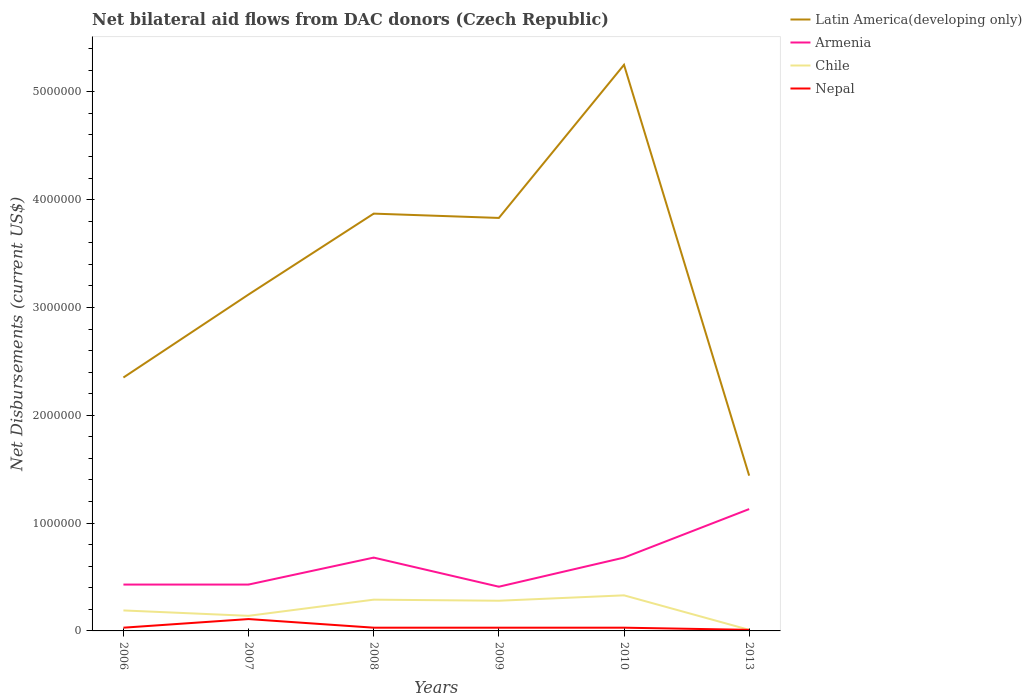How many different coloured lines are there?
Provide a succinct answer. 4. Does the line corresponding to Chile intersect with the line corresponding to Latin America(developing only)?
Provide a succinct answer. No. Across all years, what is the maximum net bilateral aid flows in Armenia?
Provide a succinct answer. 4.10e+05. In which year was the net bilateral aid flows in Latin America(developing only) maximum?
Your response must be concise. 2013. What is the total net bilateral aid flows in Nepal in the graph?
Your answer should be very brief. 8.00e+04. What is the difference between the highest and the second highest net bilateral aid flows in Armenia?
Keep it short and to the point. 7.20e+05. Is the net bilateral aid flows in Armenia strictly greater than the net bilateral aid flows in Nepal over the years?
Your answer should be very brief. No. How many years are there in the graph?
Your answer should be compact. 6. Are the values on the major ticks of Y-axis written in scientific E-notation?
Offer a terse response. No. Does the graph contain any zero values?
Your answer should be compact. No. Where does the legend appear in the graph?
Give a very brief answer. Top right. How many legend labels are there?
Ensure brevity in your answer.  4. What is the title of the graph?
Offer a terse response. Net bilateral aid flows from DAC donors (Czech Republic). Does "Hungary" appear as one of the legend labels in the graph?
Offer a terse response. No. What is the label or title of the Y-axis?
Ensure brevity in your answer.  Net Disbursements (current US$). What is the Net Disbursements (current US$) of Latin America(developing only) in 2006?
Make the answer very short. 2.35e+06. What is the Net Disbursements (current US$) in Chile in 2006?
Provide a short and direct response. 1.90e+05. What is the Net Disbursements (current US$) in Latin America(developing only) in 2007?
Give a very brief answer. 3.12e+06. What is the Net Disbursements (current US$) in Armenia in 2007?
Make the answer very short. 4.30e+05. What is the Net Disbursements (current US$) in Nepal in 2007?
Your answer should be compact. 1.10e+05. What is the Net Disbursements (current US$) of Latin America(developing only) in 2008?
Offer a very short reply. 3.87e+06. What is the Net Disbursements (current US$) of Armenia in 2008?
Your response must be concise. 6.80e+05. What is the Net Disbursements (current US$) in Chile in 2008?
Offer a very short reply. 2.90e+05. What is the Net Disbursements (current US$) in Latin America(developing only) in 2009?
Your answer should be compact. 3.83e+06. What is the Net Disbursements (current US$) in Armenia in 2009?
Your answer should be very brief. 4.10e+05. What is the Net Disbursements (current US$) in Chile in 2009?
Your answer should be compact. 2.80e+05. What is the Net Disbursements (current US$) in Latin America(developing only) in 2010?
Make the answer very short. 5.25e+06. What is the Net Disbursements (current US$) in Armenia in 2010?
Make the answer very short. 6.80e+05. What is the Net Disbursements (current US$) of Chile in 2010?
Give a very brief answer. 3.30e+05. What is the Net Disbursements (current US$) in Latin America(developing only) in 2013?
Your response must be concise. 1.44e+06. What is the Net Disbursements (current US$) in Armenia in 2013?
Your response must be concise. 1.13e+06. What is the Net Disbursements (current US$) in Chile in 2013?
Offer a very short reply. 10000. Across all years, what is the maximum Net Disbursements (current US$) of Latin America(developing only)?
Your answer should be compact. 5.25e+06. Across all years, what is the maximum Net Disbursements (current US$) of Armenia?
Provide a succinct answer. 1.13e+06. Across all years, what is the minimum Net Disbursements (current US$) of Latin America(developing only)?
Your answer should be very brief. 1.44e+06. Across all years, what is the minimum Net Disbursements (current US$) in Armenia?
Provide a short and direct response. 4.10e+05. Across all years, what is the minimum Net Disbursements (current US$) in Chile?
Offer a very short reply. 10000. Across all years, what is the minimum Net Disbursements (current US$) of Nepal?
Make the answer very short. 10000. What is the total Net Disbursements (current US$) of Latin America(developing only) in the graph?
Provide a succinct answer. 1.99e+07. What is the total Net Disbursements (current US$) in Armenia in the graph?
Give a very brief answer. 3.76e+06. What is the total Net Disbursements (current US$) in Chile in the graph?
Make the answer very short. 1.24e+06. What is the total Net Disbursements (current US$) in Nepal in the graph?
Offer a very short reply. 2.40e+05. What is the difference between the Net Disbursements (current US$) in Latin America(developing only) in 2006 and that in 2007?
Your answer should be compact. -7.70e+05. What is the difference between the Net Disbursements (current US$) of Latin America(developing only) in 2006 and that in 2008?
Give a very brief answer. -1.52e+06. What is the difference between the Net Disbursements (current US$) of Latin America(developing only) in 2006 and that in 2009?
Provide a succinct answer. -1.48e+06. What is the difference between the Net Disbursements (current US$) in Armenia in 2006 and that in 2009?
Offer a terse response. 2.00e+04. What is the difference between the Net Disbursements (current US$) of Chile in 2006 and that in 2009?
Ensure brevity in your answer.  -9.00e+04. What is the difference between the Net Disbursements (current US$) of Latin America(developing only) in 2006 and that in 2010?
Your answer should be compact. -2.90e+06. What is the difference between the Net Disbursements (current US$) of Chile in 2006 and that in 2010?
Offer a terse response. -1.40e+05. What is the difference between the Net Disbursements (current US$) in Latin America(developing only) in 2006 and that in 2013?
Make the answer very short. 9.10e+05. What is the difference between the Net Disbursements (current US$) in Armenia in 2006 and that in 2013?
Your answer should be compact. -7.00e+05. What is the difference between the Net Disbursements (current US$) in Chile in 2006 and that in 2013?
Make the answer very short. 1.80e+05. What is the difference between the Net Disbursements (current US$) of Latin America(developing only) in 2007 and that in 2008?
Your answer should be compact. -7.50e+05. What is the difference between the Net Disbursements (current US$) of Armenia in 2007 and that in 2008?
Ensure brevity in your answer.  -2.50e+05. What is the difference between the Net Disbursements (current US$) in Chile in 2007 and that in 2008?
Make the answer very short. -1.50e+05. What is the difference between the Net Disbursements (current US$) of Latin America(developing only) in 2007 and that in 2009?
Offer a very short reply. -7.10e+05. What is the difference between the Net Disbursements (current US$) in Nepal in 2007 and that in 2009?
Ensure brevity in your answer.  8.00e+04. What is the difference between the Net Disbursements (current US$) in Latin America(developing only) in 2007 and that in 2010?
Provide a short and direct response. -2.13e+06. What is the difference between the Net Disbursements (current US$) of Armenia in 2007 and that in 2010?
Your response must be concise. -2.50e+05. What is the difference between the Net Disbursements (current US$) of Chile in 2007 and that in 2010?
Your response must be concise. -1.90e+05. What is the difference between the Net Disbursements (current US$) in Nepal in 2007 and that in 2010?
Keep it short and to the point. 8.00e+04. What is the difference between the Net Disbursements (current US$) in Latin America(developing only) in 2007 and that in 2013?
Ensure brevity in your answer.  1.68e+06. What is the difference between the Net Disbursements (current US$) of Armenia in 2007 and that in 2013?
Provide a short and direct response. -7.00e+05. What is the difference between the Net Disbursements (current US$) in Chile in 2007 and that in 2013?
Offer a very short reply. 1.30e+05. What is the difference between the Net Disbursements (current US$) in Nepal in 2007 and that in 2013?
Offer a very short reply. 1.00e+05. What is the difference between the Net Disbursements (current US$) in Latin America(developing only) in 2008 and that in 2009?
Offer a very short reply. 4.00e+04. What is the difference between the Net Disbursements (current US$) of Armenia in 2008 and that in 2009?
Your answer should be very brief. 2.70e+05. What is the difference between the Net Disbursements (current US$) in Nepal in 2008 and that in 2009?
Offer a very short reply. 0. What is the difference between the Net Disbursements (current US$) of Latin America(developing only) in 2008 and that in 2010?
Your answer should be compact. -1.38e+06. What is the difference between the Net Disbursements (current US$) of Armenia in 2008 and that in 2010?
Provide a succinct answer. 0. What is the difference between the Net Disbursements (current US$) in Latin America(developing only) in 2008 and that in 2013?
Keep it short and to the point. 2.43e+06. What is the difference between the Net Disbursements (current US$) in Armenia in 2008 and that in 2013?
Offer a terse response. -4.50e+05. What is the difference between the Net Disbursements (current US$) in Chile in 2008 and that in 2013?
Provide a succinct answer. 2.80e+05. What is the difference between the Net Disbursements (current US$) in Nepal in 2008 and that in 2013?
Your answer should be very brief. 2.00e+04. What is the difference between the Net Disbursements (current US$) in Latin America(developing only) in 2009 and that in 2010?
Give a very brief answer. -1.42e+06. What is the difference between the Net Disbursements (current US$) in Nepal in 2009 and that in 2010?
Your answer should be very brief. 0. What is the difference between the Net Disbursements (current US$) of Latin America(developing only) in 2009 and that in 2013?
Ensure brevity in your answer.  2.39e+06. What is the difference between the Net Disbursements (current US$) in Armenia in 2009 and that in 2013?
Offer a very short reply. -7.20e+05. What is the difference between the Net Disbursements (current US$) of Nepal in 2009 and that in 2013?
Your answer should be compact. 2.00e+04. What is the difference between the Net Disbursements (current US$) of Latin America(developing only) in 2010 and that in 2013?
Make the answer very short. 3.81e+06. What is the difference between the Net Disbursements (current US$) of Armenia in 2010 and that in 2013?
Your response must be concise. -4.50e+05. What is the difference between the Net Disbursements (current US$) in Latin America(developing only) in 2006 and the Net Disbursements (current US$) in Armenia in 2007?
Keep it short and to the point. 1.92e+06. What is the difference between the Net Disbursements (current US$) in Latin America(developing only) in 2006 and the Net Disbursements (current US$) in Chile in 2007?
Your answer should be very brief. 2.21e+06. What is the difference between the Net Disbursements (current US$) in Latin America(developing only) in 2006 and the Net Disbursements (current US$) in Nepal in 2007?
Provide a succinct answer. 2.24e+06. What is the difference between the Net Disbursements (current US$) of Armenia in 2006 and the Net Disbursements (current US$) of Nepal in 2007?
Offer a terse response. 3.20e+05. What is the difference between the Net Disbursements (current US$) of Latin America(developing only) in 2006 and the Net Disbursements (current US$) of Armenia in 2008?
Offer a terse response. 1.67e+06. What is the difference between the Net Disbursements (current US$) in Latin America(developing only) in 2006 and the Net Disbursements (current US$) in Chile in 2008?
Offer a terse response. 2.06e+06. What is the difference between the Net Disbursements (current US$) of Latin America(developing only) in 2006 and the Net Disbursements (current US$) of Nepal in 2008?
Keep it short and to the point. 2.32e+06. What is the difference between the Net Disbursements (current US$) in Armenia in 2006 and the Net Disbursements (current US$) in Nepal in 2008?
Provide a short and direct response. 4.00e+05. What is the difference between the Net Disbursements (current US$) of Chile in 2006 and the Net Disbursements (current US$) of Nepal in 2008?
Make the answer very short. 1.60e+05. What is the difference between the Net Disbursements (current US$) in Latin America(developing only) in 2006 and the Net Disbursements (current US$) in Armenia in 2009?
Provide a short and direct response. 1.94e+06. What is the difference between the Net Disbursements (current US$) in Latin America(developing only) in 2006 and the Net Disbursements (current US$) in Chile in 2009?
Your response must be concise. 2.07e+06. What is the difference between the Net Disbursements (current US$) in Latin America(developing only) in 2006 and the Net Disbursements (current US$) in Nepal in 2009?
Your answer should be very brief. 2.32e+06. What is the difference between the Net Disbursements (current US$) in Armenia in 2006 and the Net Disbursements (current US$) in Nepal in 2009?
Offer a terse response. 4.00e+05. What is the difference between the Net Disbursements (current US$) in Chile in 2006 and the Net Disbursements (current US$) in Nepal in 2009?
Provide a succinct answer. 1.60e+05. What is the difference between the Net Disbursements (current US$) in Latin America(developing only) in 2006 and the Net Disbursements (current US$) in Armenia in 2010?
Give a very brief answer. 1.67e+06. What is the difference between the Net Disbursements (current US$) of Latin America(developing only) in 2006 and the Net Disbursements (current US$) of Chile in 2010?
Your answer should be compact. 2.02e+06. What is the difference between the Net Disbursements (current US$) of Latin America(developing only) in 2006 and the Net Disbursements (current US$) of Nepal in 2010?
Offer a very short reply. 2.32e+06. What is the difference between the Net Disbursements (current US$) in Armenia in 2006 and the Net Disbursements (current US$) in Chile in 2010?
Provide a succinct answer. 1.00e+05. What is the difference between the Net Disbursements (current US$) of Chile in 2006 and the Net Disbursements (current US$) of Nepal in 2010?
Make the answer very short. 1.60e+05. What is the difference between the Net Disbursements (current US$) of Latin America(developing only) in 2006 and the Net Disbursements (current US$) of Armenia in 2013?
Give a very brief answer. 1.22e+06. What is the difference between the Net Disbursements (current US$) in Latin America(developing only) in 2006 and the Net Disbursements (current US$) in Chile in 2013?
Your answer should be very brief. 2.34e+06. What is the difference between the Net Disbursements (current US$) in Latin America(developing only) in 2006 and the Net Disbursements (current US$) in Nepal in 2013?
Your response must be concise. 2.34e+06. What is the difference between the Net Disbursements (current US$) in Armenia in 2006 and the Net Disbursements (current US$) in Chile in 2013?
Provide a succinct answer. 4.20e+05. What is the difference between the Net Disbursements (current US$) of Armenia in 2006 and the Net Disbursements (current US$) of Nepal in 2013?
Your response must be concise. 4.20e+05. What is the difference between the Net Disbursements (current US$) of Latin America(developing only) in 2007 and the Net Disbursements (current US$) of Armenia in 2008?
Make the answer very short. 2.44e+06. What is the difference between the Net Disbursements (current US$) in Latin America(developing only) in 2007 and the Net Disbursements (current US$) in Chile in 2008?
Give a very brief answer. 2.83e+06. What is the difference between the Net Disbursements (current US$) in Latin America(developing only) in 2007 and the Net Disbursements (current US$) in Nepal in 2008?
Your answer should be compact. 3.09e+06. What is the difference between the Net Disbursements (current US$) in Armenia in 2007 and the Net Disbursements (current US$) in Chile in 2008?
Your response must be concise. 1.40e+05. What is the difference between the Net Disbursements (current US$) of Armenia in 2007 and the Net Disbursements (current US$) of Nepal in 2008?
Make the answer very short. 4.00e+05. What is the difference between the Net Disbursements (current US$) of Latin America(developing only) in 2007 and the Net Disbursements (current US$) of Armenia in 2009?
Your answer should be very brief. 2.71e+06. What is the difference between the Net Disbursements (current US$) in Latin America(developing only) in 2007 and the Net Disbursements (current US$) in Chile in 2009?
Provide a short and direct response. 2.84e+06. What is the difference between the Net Disbursements (current US$) in Latin America(developing only) in 2007 and the Net Disbursements (current US$) in Nepal in 2009?
Provide a succinct answer. 3.09e+06. What is the difference between the Net Disbursements (current US$) in Chile in 2007 and the Net Disbursements (current US$) in Nepal in 2009?
Give a very brief answer. 1.10e+05. What is the difference between the Net Disbursements (current US$) in Latin America(developing only) in 2007 and the Net Disbursements (current US$) in Armenia in 2010?
Ensure brevity in your answer.  2.44e+06. What is the difference between the Net Disbursements (current US$) in Latin America(developing only) in 2007 and the Net Disbursements (current US$) in Chile in 2010?
Provide a short and direct response. 2.79e+06. What is the difference between the Net Disbursements (current US$) of Latin America(developing only) in 2007 and the Net Disbursements (current US$) of Nepal in 2010?
Provide a short and direct response. 3.09e+06. What is the difference between the Net Disbursements (current US$) of Latin America(developing only) in 2007 and the Net Disbursements (current US$) of Armenia in 2013?
Offer a terse response. 1.99e+06. What is the difference between the Net Disbursements (current US$) of Latin America(developing only) in 2007 and the Net Disbursements (current US$) of Chile in 2013?
Keep it short and to the point. 3.11e+06. What is the difference between the Net Disbursements (current US$) of Latin America(developing only) in 2007 and the Net Disbursements (current US$) of Nepal in 2013?
Offer a terse response. 3.11e+06. What is the difference between the Net Disbursements (current US$) in Armenia in 2007 and the Net Disbursements (current US$) in Chile in 2013?
Offer a terse response. 4.20e+05. What is the difference between the Net Disbursements (current US$) in Armenia in 2007 and the Net Disbursements (current US$) in Nepal in 2013?
Make the answer very short. 4.20e+05. What is the difference between the Net Disbursements (current US$) of Chile in 2007 and the Net Disbursements (current US$) of Nepal in 2013?
Offer a terse response. 1.30e+05. What is the difference between the Net Disbursements (current US$) in Latin America(developing only) in 2008 and the Net Disbursements (current US$) in Armenia in 2009?
Your answer should be very brief. 3.46e+06. What is the difference between the Net Disbursements (current US$) of Latin America(developing only) in 2008 and the Net Disbursements (current US$) of Chile in 2009?
Ensure brevity in your answer.  3.59e+06. What is the difference between the Net Disbursements (current US$) in Latin America(developing only) in 2008 and the Net Disbursements (current US$) in Nepal in 2009?
Offer a very short reply. 3.84e+06. What is the difference between the Net Disbursements (current US$) of Armenia in 2008 and the Net Disbursements (current US$) of Nepal in 2009?
Ensure brevity in your answer.  6.50e+05. What is the difference between the Net Disbursements (current US$) of Chile in 2008 and the Net Disbursements (current US$) of Nepal in 2009?
Your answer should be very brief. 2.60e+05. What is the difference between the Net Disbursements (current US$) of Latin America(developing only) in 2008 and the Net Disbursements (current US$) of Armenia in 2010?
Make the answer very short. 3.19e+06. What is the difference between the Net Disbursements (current US$) in Latin America(developing only) in 2008 and the Net Disbursements (current US$) in Chile in 2010?
Offer a very short reply. 3.54e+06. What is the difference between the Net Disbursements (current US$) of Latin America(developing only) in 2008 and the Net Disbursements (current US$) of Nepal in 2010?
Make the answer very short. 3.84e+06. What is the difference between the Net Disbursements (current US$) of Armenia in 2008 and the Net Disbursements (current US$) of Nepal in 2010?
Your answer should be very brief. 6.50e+05. What is the difference between the Net Disbursements (current US$) of Latin America(developing only) in 2008 and the Net Disbursements (current US$) of Armenia in 2013?
Offer a terse response. 2.74e+06. What is the difference between the Net Disbursements (current US$) of Latin America(developing only) in 2008 and the Net Disbursements (current US$) of Chile in 2013?
Your answer should be very brief. 3.86e+06. What is the difference between the Net Disbursements (current US$) in Latin America(developing only) in 2008 and the Net Disbursements (current US$) in Nepal in 2013?
Offer a terse response. 3.86e+06. What is the difference between the Net Disbursements (current US$) in Armenia in 2008 and the Net Disbursements (current US$) in Chile in 2013?
Give a very brief answer. 6.70e+05. What is the difference between the Net Disbursements (current US$) in Armenia in 2008 and the Net Disbursements (current US$) in Nepal in 2013?
Your answer should be very brief. 6.70e+05. What is the difference between the Net Disbursements (current US$) in Latin America(developing only) in 2009 and the Net Disbursements (current US$) in Armenia in 2010?
Provide a succinct answer. 3.15e+06. What is the difference between the Net Disbursements (current US$) of Latin America(developing only) in 2009 and the Net Disbursements (current US$) of Chile in 2010?
Offer a terse response. 3.50e+06. What is the difference between the Net Disbursements (current US$) of Latin America(developing only) in 2009 and the Net Disbursements (current US$) of Nepal in 2010?
Your response must be concise. 3.80e+06. What is the difference between the Net Disbursements (current US$) of Chile in 2009 and the Net Disbursements (current US$) of Nepal in 2010?
Offer a very short reply. 2.50e+05. What is the difference between the Net Disbursements (current US$) in Latin America(developing only) in 2009 and the Net Disbursements (current US$) in Armenia in 2013?
Give a very brief answer. 2.70e+06. What is the difference between the Net Disbursements (current US$) of Latin America(developing only) in 2009 and the Net Disbursements (current US$) of Chile in 2013?
Provide a succinct answer. 3.82e+06. What is the difference between the Net Disbursements (current US$) in Latin America(developing only) in 2009 and the Net Disbursements (current US$) in Nepal in 2013?
Ensure brevity in your answer.  3.82e+06. What is the difference between the Net Disbursements (current US$) of Latin America(developing only) in 2010 and the Net Disbursements (current US$) of Armenia in 2013?
Your answer should be very brief. 4.12e+06. What is the difference between the Net Disbursements (current US$) of Latin America(developing only) in 2010 and the Net Disbursements (current US$) of Chile in 2013?
Make the answer very short. 5.24e+06. What is the difference between the Net Disbursements (current US$) of Latin America(developing only) in 2010 and the Net Disbursements (current US$) of Nepal in 2013?
Offer a terse response. 5.24e+06. What is the difference between the Net Disbursements (current US$) in Armenia in 2010 and the Net Disbursements (current US$) in Chile in 2013?
Your answer should be very brief. 6.70e+05. What is the difference between the Net Disbursements (current US$) of Armenia in 2010 and the Net Disbursements (current US$) of Nepal in 2013?
Offer a terse response. 6.70e+05. What is the average Net Disbursements (current US$) of Latin America(developing only) per year?
Your answer should be very brief. 3.31e+06. What is the average Net Disbursements (current US$) of Armenia per year?
Offer a very short reply. 6.27e+05. What is the average Net Disbursements (current US$) in Chile per year?
Your answer should be very brief. 2.07e+05. In the year 2006, what is the difference between the Net Disbursements (current US$) of Latin America(developing only) and Net Disbursements (current US$) of Armenia?
Your answer should be very brief. 1.92e+06. In the year 2006, what is the difference between the Net Disbursements (current US$) in Latin America(developing only) and Net Disbursements (current US$) in Chile?
Give a very brief answer. 2.16e+06. In the year 2006, what is the difference between the Net Disbursements (current US$) of Latin America(developing only) and Net Disbursements (current US$) of Nepal?
Make the answer very short. 2.32e+06. In the year 2006, what is the difference between the Net Disbursements (current US$) of Chile and Net Disbursements (current US$) of Nepal?
Give a very brief answer. 1.60e+05. In the year 2007, what is the difference between the Net Disbursements (current US$) of Latin America(developing only) and Net Disbursements (current US$) of Armenia?
Provide a succinct answer. 2.69e+06. In the year 2007, what is the difference between the Net Disbursements (current US$) of Latin America(developing only) and Net Disbursements (current US$) of Chile?
Offer a very short reply. 2.98e+06. In the year 2007, what is the difference between the Net Disbursements (current US$) of Latin America(developing only) and Net Disbursements (current US$) of Nepal?
Offer a very short reply. 3.01e+06. In the year 2008, what is the difference between the Net Disbursements (current US$) in Latin America(developing only) and Net Disbursements (current US$) in Armenia?
Offer a very short reply. 3.19e+06. In the year 2008, what is the difference between the Net Disbursements (current US$) in Latin America(developing only) and Net Disbursements (current US$) in Chile?
Your answer should be compact. 3.58e+06. In the year 2008, what is the difference between the Net Disbursements (current US$) of Latin America(developing only) and Net Disbursements (current US$) of Nepal?
Your answer should be very brief. 3.84e+06. In the year 2008, what is the difference between the Net Disbursements (current US$) in Armenia and Net Disbursements (current US$) in Nepal?
Provide a succinct answer. 6.50e+05. In the year 2009, what is the difference between the Net Disbursements (current US$) in Latin America(developing only) and Net Disbursements (current US$) in Armenia?
Provide a short and direct response. 3.42e+06. In the year 2009, what is the difference between the Net Disbursements (current US$) in Latin America(developing only) and Net Disbursements (current US$) in Chile?
Offer a terse response. 3.55e+06. In the year 2009, what is the difference between the Net Disbursements (current US$) in Latin America(developing only) and Net Disbursements (current US$) in Nepal?
Provide a short and direct response. 3.80e+06. In the year 2009, what is the difference between the Net Disbursements (current US$) of Chile and Net Disbursements (current US$) of Nepal?
Provide a succinct answer. 2.50e+05. In the year 2010, what is the difference between the Net Disbursements (current US$) of Latin America(developing only) and Net Disbursements (current US$) of Armenia?
Keep it short and to the point. 4.57e+06. In the year 2010, what is the difference between the Net Disbursements (current US$) of Latin America(developing only) and Net Disbursements (current US$) of Chile?
Your answer should be very brief. 4.92e+06. In the year 2010, what is the difference between the Net Disbursements (current US$) in Latin America(developing only) and Net Disbursements (current US$) in Nepal?
Give a very brief answer. 5.22e+06. In the year 2010, what is the difference between the Net Disbursements (current US$) in Armenia and Net Disbursements (current US$) in Chile?
Provide a succinct answer. 3.50e+05. In the year 2010, what is the difference between the Net Disbursements (current US$) of Armenia and Net Disbursements (current US$) of Nepal?
Offer a terse response. 6.50e+05. In the year 2013, what is the difference between the Net Disbursements (current US$) in Latin America(developing only) and Net Disbursements (current US$) in Chile?
Provide a succinct answer. 1.43e+06. In the year 2013, what is the difference between the Net Disbursements (current US$) of Latin America(developing only) and Net Disbursements (current US$) of Nepal?
Your answer should be very brief. 1.43e+06. In the year 2013, what is the difference between the Net Disbursements (current US$) of Armenia and Net Disbursements (current US$) of Chile?
Your response must be concise. 1.12e+06. In the year 2013, what is the difference between the Net Disbursements (current US$) in Armenia and Net Disbursements (current US$) in Nepal?
Provide a succinct answer. 1.12e+06. What is the ratio of the Net Disbursements (current US$) in Latin America(developing only) in 2006 to that in 2007?
Offer a terse response. 0.75. What is the ratio of the Net Disbursements (current US$) in Armenia in 2006 to that in 2007?
Your answer should be compact. 1. What is the ratio of the Net Disbursements (current US$) in Chile in 2006 to that in 2007?
Offer a very short reply. 1.36. What is the ratio of the Net Disbursements (current US$) in Nepal in 2006 to that in 2007?
Give a very brief answer. 0.27. What is the ratio of the Net Disbursements (current US$) in Latin America(developing only) in 2006 to that in 2008?
Make the answer very short. 0.61. What is the ratio of the Net Disbursements (current US$) in Armenia in 2006 to that in 2008?
Provide a short and direct response. 0.63. What is the ratio of the Net Disbursements (current US$) of Chile in 2006 to that in 2008?
Your answer should be compact. 0.66. What is the ratio of the Net Disbursements (current US$) in Nepal in 2006 to that in 2008?
Ensure brevity in your answer.  1. What is the ratio of the Net Disbursements (current US$) in Latin America(developing only) in 2006 to that in 2009?
Offer a very short reply. 0.61. What is the ratio of the Net Disbursements (current US$) of Armenia in 2006 to that in 2009?
Offer a terse response. 1.05. What is the ratio of the Net Disbursements (current US$) of Chile in 2006 to that in 2009?
Your answer should be very brief. 0.68. What is the ratio of the Net Disbursements (current US$) of Latin America(developing only) in 2006 to that in 2010?
Provide a short and direct response. 0.45. What is the ratio of the Net Disbursements (current US$) of Armenia in 2006 to that in 2010?
Ensure brevity in your answer.  0.63. What is the ratio of the Net Disbursements (current US$) in Chile in 2006 to that in 2010?
Offer a very short reply. 0.58. What is the ratio of the Net Disbursements (current US$) of Latin America(developing only) in 2006 to that in 2013?
Ensure brevity in your answer.  1.63. What is the ratio of the Net Disbursements (current US$) in Armenia in 2006 to that in 2013?
Ensure brevity in your answer.  0.38. What is the ratio of the Net Disbursements (current US$) in Nepal in 2006 to that in 2013?
Your answer should be very brief. 3. What is the ratio of the Net Disbursements (current US$) of Latin America(developing only) in 2007 to that in 2008?
Give a very brief answer. 0.81. What is the ratio of the Net Disbursements (current US$) of Armenia in 2007 to that in 2008?
Offer a terse response. 0.63. What is the ratio of the Net Disbursements (current US$) in Chile in 2007 to that in 2008?
Ensure brevity in your answer.  0.48. What is the ratio of the Net Disbursements (current US$) in Nepal in 2007 to that in 2008?
Give a very brief answer. 3.67. What is the ratio of the Net Disbursements (current US$) in Latin America(developing only) in 2007 to that in 2009?
Make the answer very short. 0.81. What is the ratio of the Net Disbursements (current US$) in Armenia in 2007 to that in 2009?
Offer a very short reply. 1.05. What is the ratio of the Net Disbursements (current US$) of Nepal in 2007 to that in 2009?
Offer a terse response. 3.67. What is the ratio of the Net Disbursements (current US$) of Latin America(developing only) in 2007 to that in 2010?
Provide a succinct answer. 0.59. What is the ratio of the Net Disbursements (current US$) of Armenia in 2007 to that in 2010?
Provide a short and direct response. 0.63. What is the ratio of the Net Disbursements (current US$) of Chile in 2007 to that in 2010?
Keep it short and to the point. 0.42. What is the ratio of the Net Disbursements (current US$) of Nepal in 2007 to that in 2010?
Ensure brevity in your answer.  3.67. What is the ratio of the Net Disbursements (current US$) of Latin America(developing only) in 2007 to that in 2013?
Your answer should be very brief. 2.17. What is the ratio of the Net Disbursements (current US$) in Armenia in 2007 to that in 2013?
Your response must be concise. 0.38. What is the ratio of the Net Disbursements (current US$) of Nepal in 2007 to that in 2013?
Provide a succinct answer. 11. What is the ratio of the Net Disbursements (current US$) in Latin America(developing only) in 2008 to that in 2009?
Ensure brevity in your answer.  1.01. What is the ratio of the Net Disbursements (current US$) in Armenia in 2008 to that in 2009?
Your answer should be compact. 1.66. What is the ratio of the Net Disbursements (current US$) in Chile in 2008 to that in 2009?
Keep it short and to the point. 1.04. What is the ratio of the Net Disbursements (current US$) in Nepal in 2008 to that in 2009?
Keep it short and to the point. 1. What is the ratio of the Net Disbursements (current US$) of Latin America(developing only) in 2008 to that in 2010?
Make the answer very short. 0.74. What is the ratio of the Net Disbursements (current US$) of Armenia in 2008 to that in 2010?
Ensure brevity in your answer.  1. What is the ratio of the Net Disbursements (current US$) in Chile in 2008 to that in 2010?
Your answer should be very brief. 0.88. What is the ratio of the Net Disbursements (current US$) in Latin America(developing only) in 2008 to that in 2013?
Provide a short and direct response. 2.69. What is the ratio of the Net Disbursements (current US$) in Armenia in 2008 to that in 2013?
Your answer should be compact. 0.6. What is the ratio of the Net Disbursements (current US$) of Chile in 2008 to that in 2013?
Make the answer very short. 29. What is the ratio of the Net Disbursements (current US$) in Nepal in 2008 to that in 2013?
Offer a very short reply. 3. What is the ratio of the Net Disbursements (current US$) of Latin America(developing only) in 2009 to that in 2010?
Offer a terse response. 0.73. What is the ratio of the Net Disbursements (current US$) in Armenia in 2009 to that in 2010?
Provide a short and direct response. 0.6. What is the ratio of the Net Disbursements (current US$) in Chile in 2009 to that in 2010?
Provide a succinct answer. 0.85. What is the ratio of the Net Disbursements (current US$) in Nepal in 2009 to that in 2010?
Keep it short and to the point. 1. What is the ratio of the Net Disbursements (current US$) in Latin America(developing only) in 2009 to that in 2013?
Offer a very short reply. 2.66. What is the ratio of the Net Disbursements (current US$) of Armenia in 2009 to that in 2013?
Offer a very short reply. 0.36. What is the ratio of the Net Disbursements (current US$) of Nepal in 2009 to that in 2013?
Offer a very short reply. 3. What is the ratio of the Net Disbursements (current US$) of Latin America(developing only) in 2010 to that in 2013?
Your answer should be compact. 3.65. What is the ratio of the Net Disbursements (current US$) of Armenia in 2010 to that in 2013?
Offer a terse response. 0.6. What is the ratio of the Net Disbursements (current US$) in Chile in 2010 to that in 2013?
Keep it short and to the point. 33. What is the difference between the highest and the second highest Net Disbursements (current US$) in Latin America(developing only)?
Offer a very short reply. 1.38e+06. What is the difference between the highest and the second highest Net Disbursements (current US$) of Armenia?
Your response must be concise. 4.50e+05. What is the difference between the highest and the second highest Net Disbursements (current US$) of Chile?
Offer a terse response. 4.00e+04. What is the difference between the highest and the second highest Net Disbursements (current US$) in Nepal?
Make the answer very short. 8.00e+04. What is the difference between the highest and the lowest Net Disbursements (current US$) in Latin America(developing only)?
Ensure brevity in your answer.  3.81e+06. What is the difference between the highest and the lowest Net Disbursements (current US$) of Armenia?
Make the answer very short. 7.20e+05. What is the difference between the highest and the lowest Net Disbursements (current US$) in Chile?
Provide a succinct answer. 3.20e+05. What is the difference between the highest and the lowest Net Disbursements (current US$) in Nepal?
Make the answer very short. 1.00e+05. 